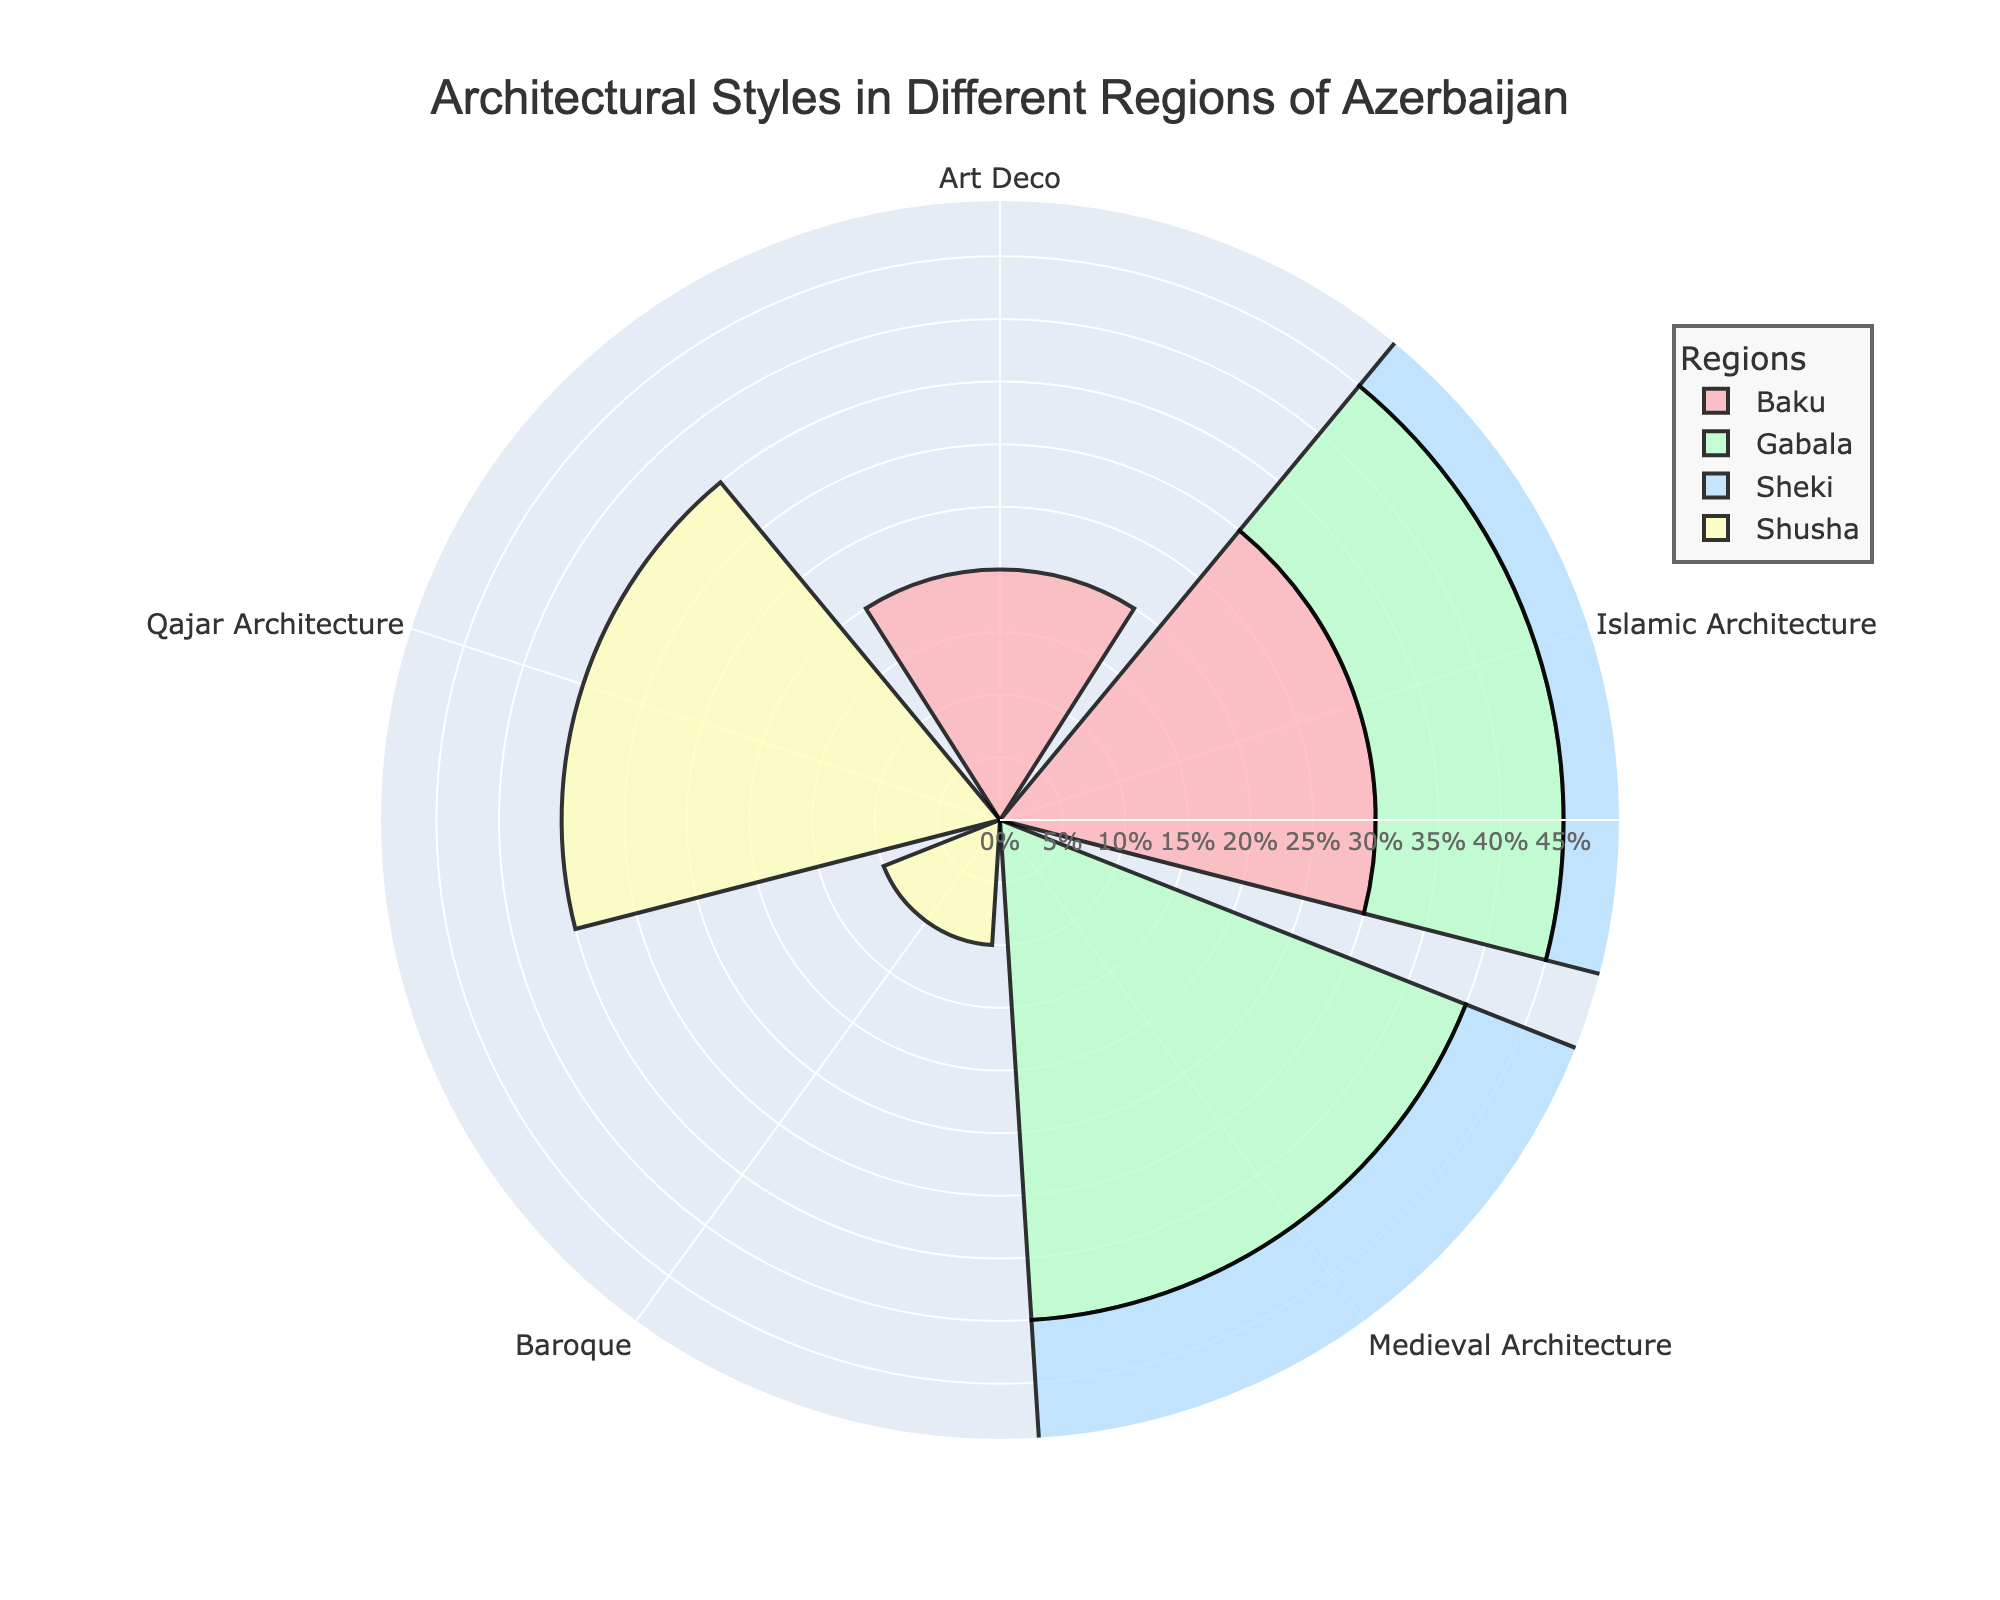What architectural style has the highest percentage in Baku? In the region of Baku, Islamic Architecture has a percentage of 30, while Art Deco has 20. Therefore, Islamic Architecture has the highest percentage.
Answer: Islamic Architecture Which region has the highest percentage of Medieval Architecture? We need to look at the percentages of Medieval Architecture in all the regions. In Gabala, it is 40%, and in Sheki, it is 45%. Therefore, Sheki has the highest percentage for Medieval Architecture.
Answer: Sheki What is the combined percentage of Islamic Architecture across all regions? Add the percentages of Islamic Architecture across different regions (Baku: 30%, Gabala: 15%, Sheki: 25%). The combined percentage is 30 + 15 + 25 = 70%.
Answer: 70% Which region has the lowest representation of Baroque architecture in the figure? The only region that features Baroque architecture is Shusha with a percentage of 10%. Therefore, in relation to other regions and architectures, Shusha has the lowest representation.
Answer: Shusha What is the most prominent architectural style in Gabala? In Gabala, Medieval Architecture has a percentage of 40%, and Islamic Architecture has 15%. Hence, Medieval Architecture is the most prominent style in Gabala.
Answer: Medieval Architecture Compare the percentages of Qajar Architecture in Shusha and Art Deco in Baku. Which is higher? The percentage of Qajar Architecture in Shusha is 35%, while the percentage of Art Deco in Baku is 20%. Therefore, Qajar Architecture in Shusha is higher.
Answer: Qajar Architecture What percentage of the chart is represented by Shusha overall? Sum the percentages of Qajar Architecture and Baroque in Shusha: 35% + 10% = 45%.
Answer: 45% How does the proportion of Medieval Architecture in Gabala compare to that in Sheki? In Gabala, Medieval Architecture is 40%; in Sheki, it is 45%. Thus, Medieval Architecture is slightly more prominent in Sheki than in Gabala.
Answer: Sheki What portion of Gabala's total architectural styles is not Islamic Architecture? Gabala has percentages of 40% for Medieval Architecture and 15% for Islamic Architecture. To find the non-Islamic portion, subtract the Islamic percentage from 100%: 100% - 15% = 85%.
Answer: 85% 